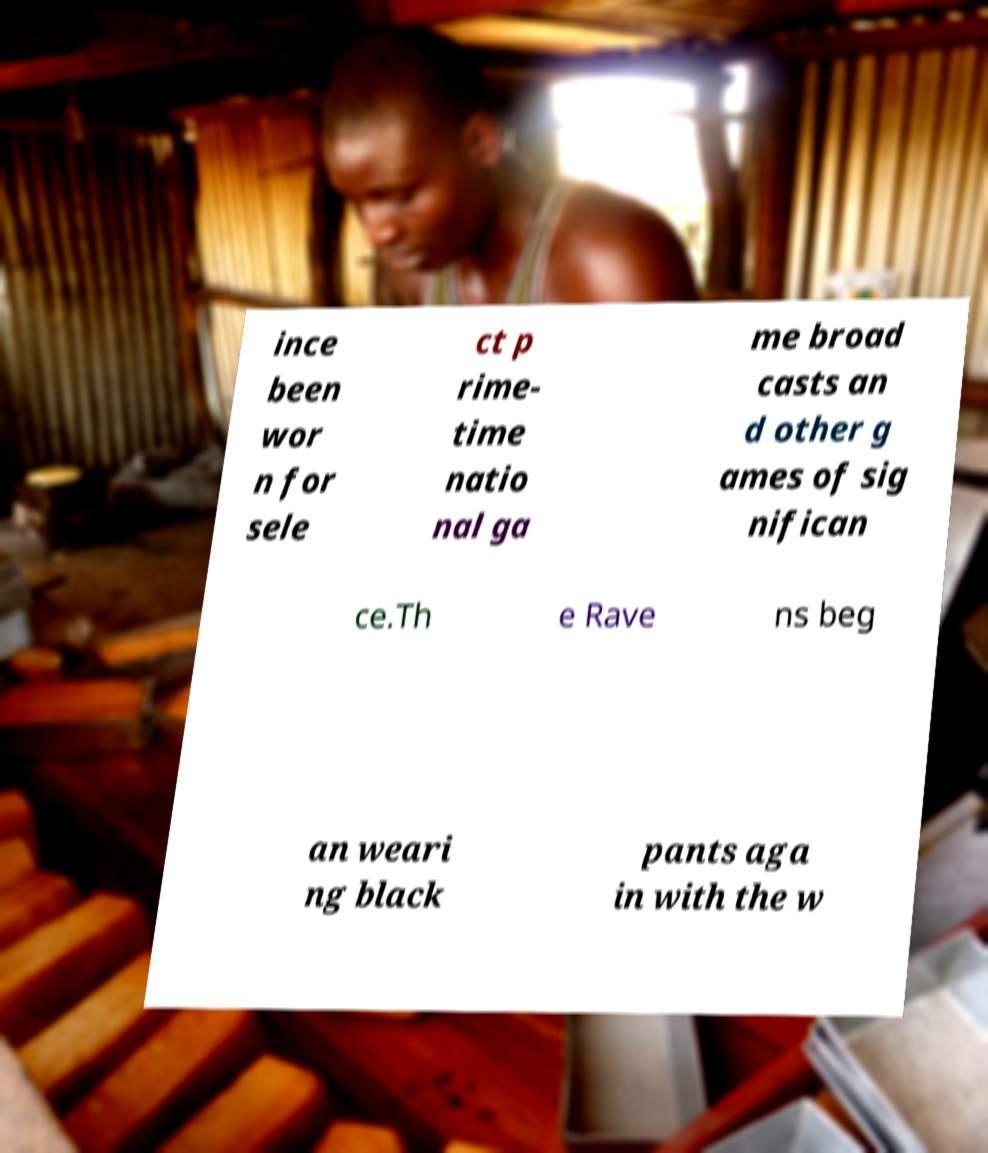Please identify and transcribe the text found in this image. ince been wor n for sele ct p rime- time natio nal ga me broad casts an d other g ames of sig nifican ce.Th e Rave ns beg an weari ng black pants aga in with the w 